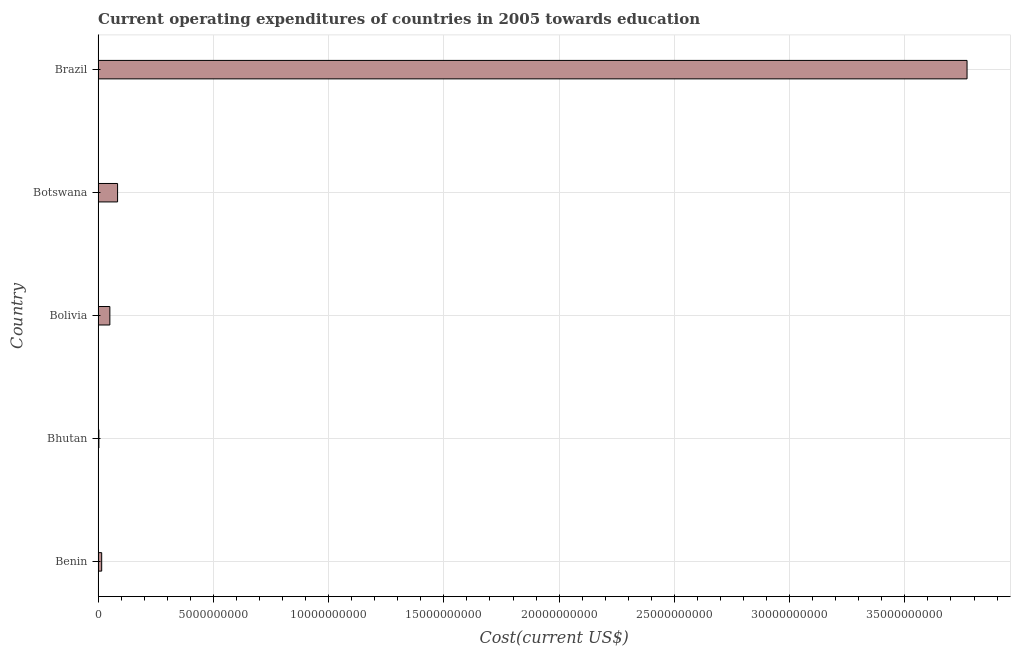Does the graph contain any zero values?
Your answer should be very brief. No. Does the graph contain grids?
Offer a terse response. Yes. What is the title of the graph?
Your response must be concise. Current operating expenditures of countries in 2005 towards education. What is the label or title of the X-axis?
Offer a terse response. Cost(current US$). What is the education expenditure in Bolivia?
Keep it short and to the point. 5.11e+08. Across all countries, what is the maximum education expenditure?
Offer a very short reply. 3.77e+1. Across all countries, what is the minimum education expenditure?
Your answer should be compact. 3.47e+07. In which country was the education expenditure maximum?
Offer a terse response. Brazil. In which country was the education expenditure minimum?
Give a very brief answer. Bhutan. What is the sum of the education expenditure?
Your response must be concise. 3.92e+1. What is the difference between the education expenditure in Bhutan and Botswana?
Make the answer very short. -8.11e+08. What is the average education expenditure per country?
Offer a terse response. 7.85e+09. What is the median education expenditure?
Give a very brief answer. 5.11e+08. What is the ratio of the education expenditure in Bhutan to that in Bolivia?
Offer a terse response. 0.07. What is the difference between the highest and the second highest education expenditure?
Offer a terse response. 3.69e+1. Is the sum of the education expenditure in Bhutan and Brazil greater than the maximum education expenditure across all countries?
Make the answer very short. Yes. What is the difference between the highest and the lowest education expenditure?
Provide a succinct answer. 3.77e+1. How many bars are there?
Provide a short and direct response. 5. How many countries are there in the graph?
Provide a short and direct response. 5. What is the difference between two consecutive major ticks on the X-axis?
Your answer should be compact. 5.00e+09. What is the Cost(current US$) in Benin?
Your answer should be very brief. 1.56e+08. What is the Cost(current US$) in Bhutan?
Provide a succinct answer. 3.47e+07. What is the Cost(current US$) of Bolivia?
Offer a terse response. 5.11e+08. What is the Cost(current US$) of Botswana?
Your answer should be very brief. 8.46e+08. What is the Cost(current US$) of Brazil?
Make the answer very short. 3.77e+1. What is the difference between the Cost(current US$) in Benin and Bhutan?
Provide a short and direct response. 1.22e+08. What is the difference between the Cost(current US$) in Benin and Bolivia?
Offer a very short reply. -3.54e+08. What is the difference between the Cost(current US$) in Benin and Botswana?
Ensure brevity in your answer.  -6.90e+08. What is the difference between the Cost(current US$) in Benin and Brazil?
Your response must be concise. -3.75e+1. What is the difference between the Cost(current US$) in Bhutan and Bolivia?
Your answer should be very brief. -4.76e+08. What is the difference between the Cost(current US$) in Bhutan and Botswana?
Keep it short and to the point. -8.11e+08. What is the difference between the Cost(current US$) in Bhutan and Brazil?
Ensure brevity in your answer.  -3.77e+1. What is the difference between the Cost(current US$) in Bolivia and Botswana?
Your answer should be compact. -3.35e+08. What is the difference between the Cost(current US$) in Bolivia and Brazil?
Ensure brevity in your answer.  -3.72e+1. What is the difference between the Cost(current US$) in Botswana and Brazil?
Provide a succinct answer. -3.69e+1. What is the ratio of the Cost(current US$) in Benin to that in Bhutan?
Your answer should be compact. 4.5. What is the ratio of the Cost(current US$) in Benin to that in Bolivia?
Give a very brief answer. 0.31. What is the ratio of the Cost(current US$) in Benin to that in Botswana?
Offer a terse response. 0.18. What is the ratio of the Cost(current US$) in Benin to that in Brazil?
Provide a succinct answer. 0. What is the ratio of the Cost(current US$) in Bhutan to that in Bolivia?
Keep it short and to the point. 0.07. What is the ratio of the Cost(current US$) in Bhutan to that in Botswana?
Your answer should be very brief. 0.04. What is the ratio of the Cost(current US$) in Bolivia to that in Botswana?
Keep it short and to the point. 0.6. What is the ratio of the Cost(current US$) in Bolivia to that in Brazil?
Ensure brevity in your answer.  0.01. What is the ratio of the Cost(current US$) in Botswana to that in Brazil?
Ensure brevity in your answer.  0.02. 